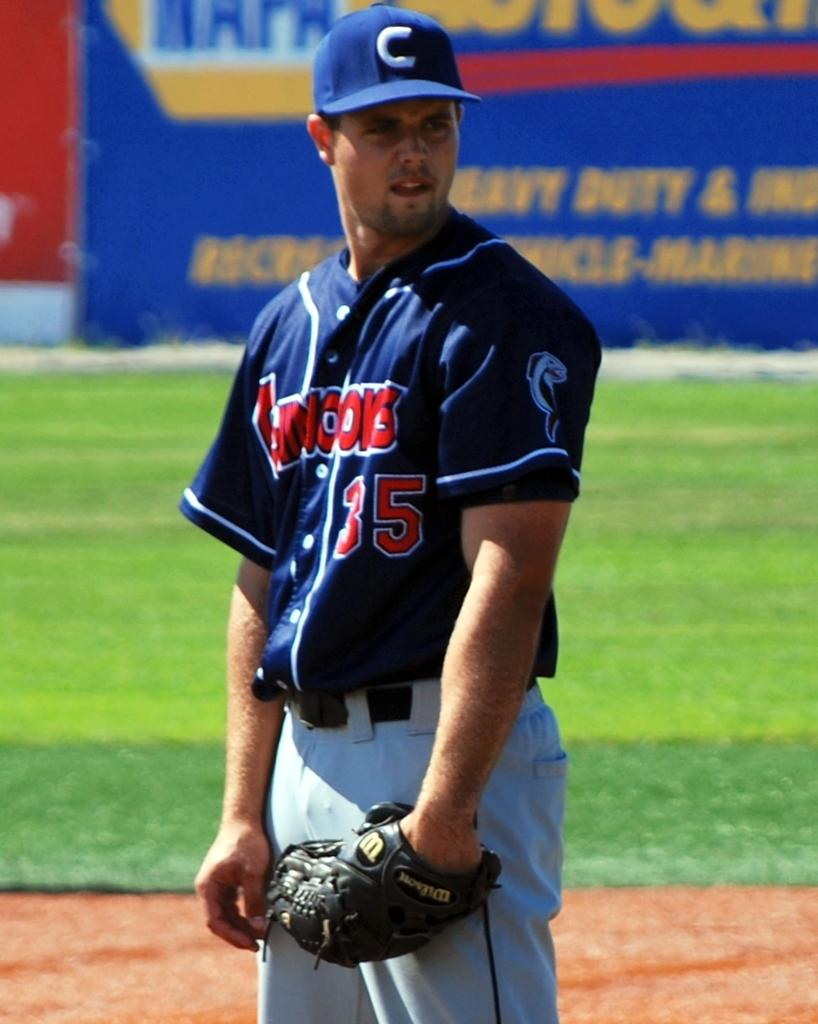<image>
Present a compact description of the photo's key features. A baseball player stands on the field with a NAPA ad behind him. 